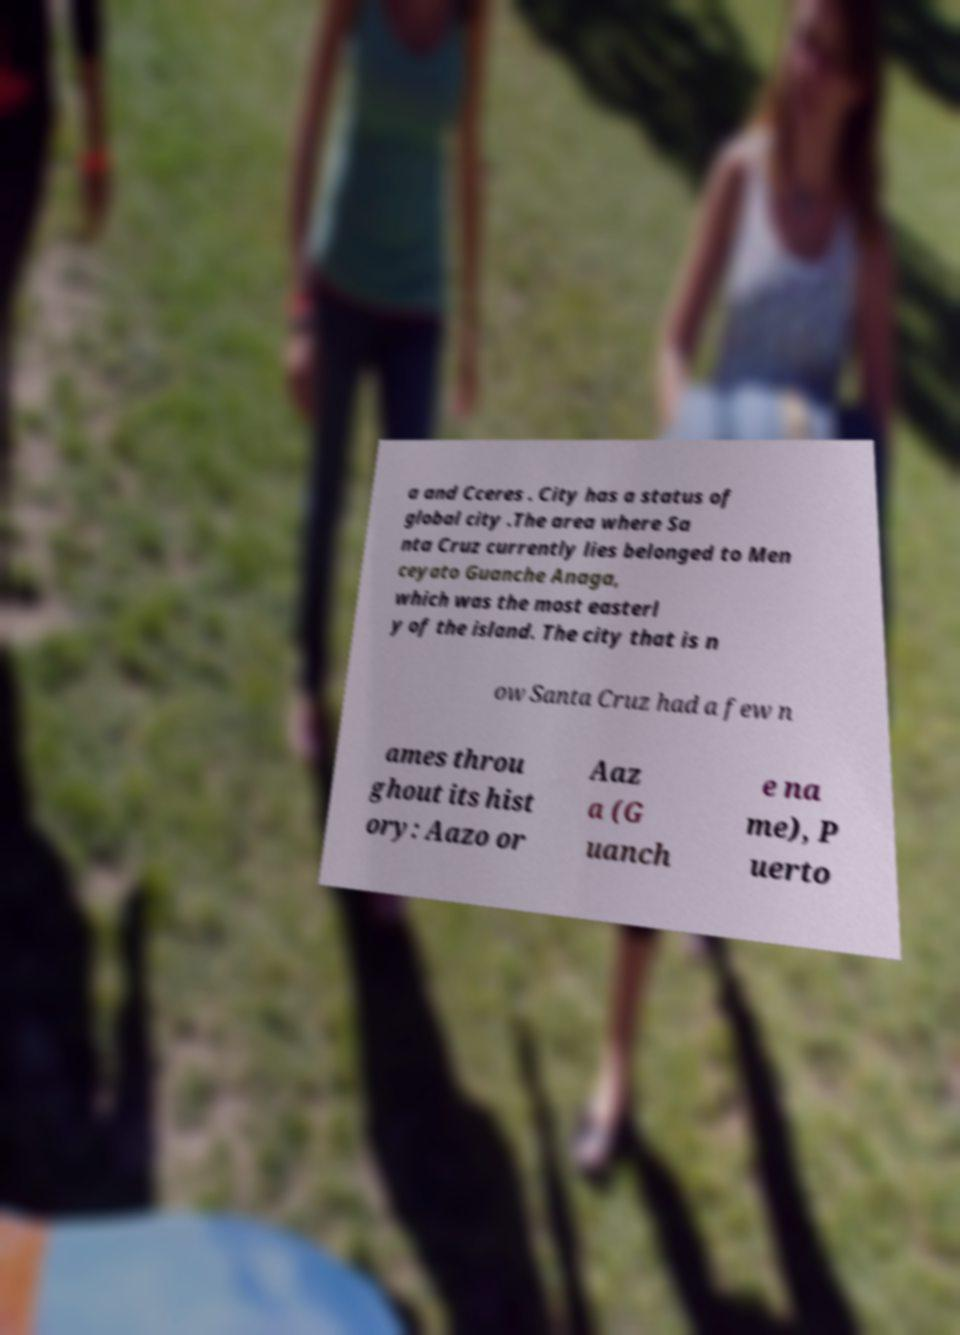Can you read and provide the text displayed in the image?This photo seems to have some interesting text. Can you extract and type it out for me? a and Cceres . City has a status of global city .The area where Sa nta Cruz currently lies belonged to Men ceyato Guanche Anaga, which was the most easterl y of the island. The city that is n ow Santa Cruz had a few n ames throu ghout its hist ory: Aazo or Aaz a (G uanch e na me), P uerto 